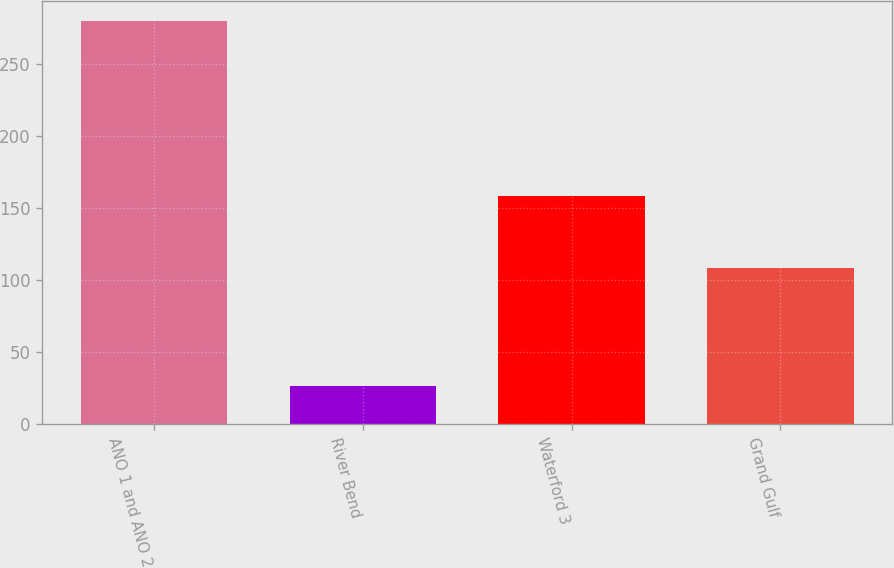Convert chart. <chart><loc_0><loc_0><loc_500><loc_500><bar_chart><fcel>ANO 1 and ANO 2<fcel>River Bend<fcel>Waterford 3<fcel>Grand Gulf<nl><fcel>280.3<fcel>26.8<fcel>158.5<fcel>108.6<nl></chart> 